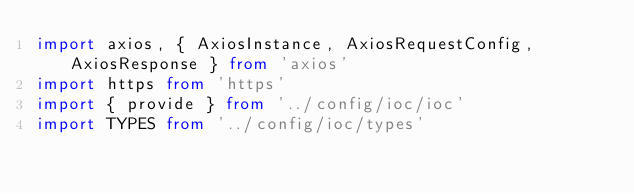<code> <loc_0><loc_0><loc_500><loc_500><_TypeScript_>import axios, { AxiosInstance, AxiosRequestConfig, AxiosResponse } from 'axios'
import https from 'https'
import { provide } from '../config/ioc/ioc'
import TYPES from '../config/ioc/types'</code> 